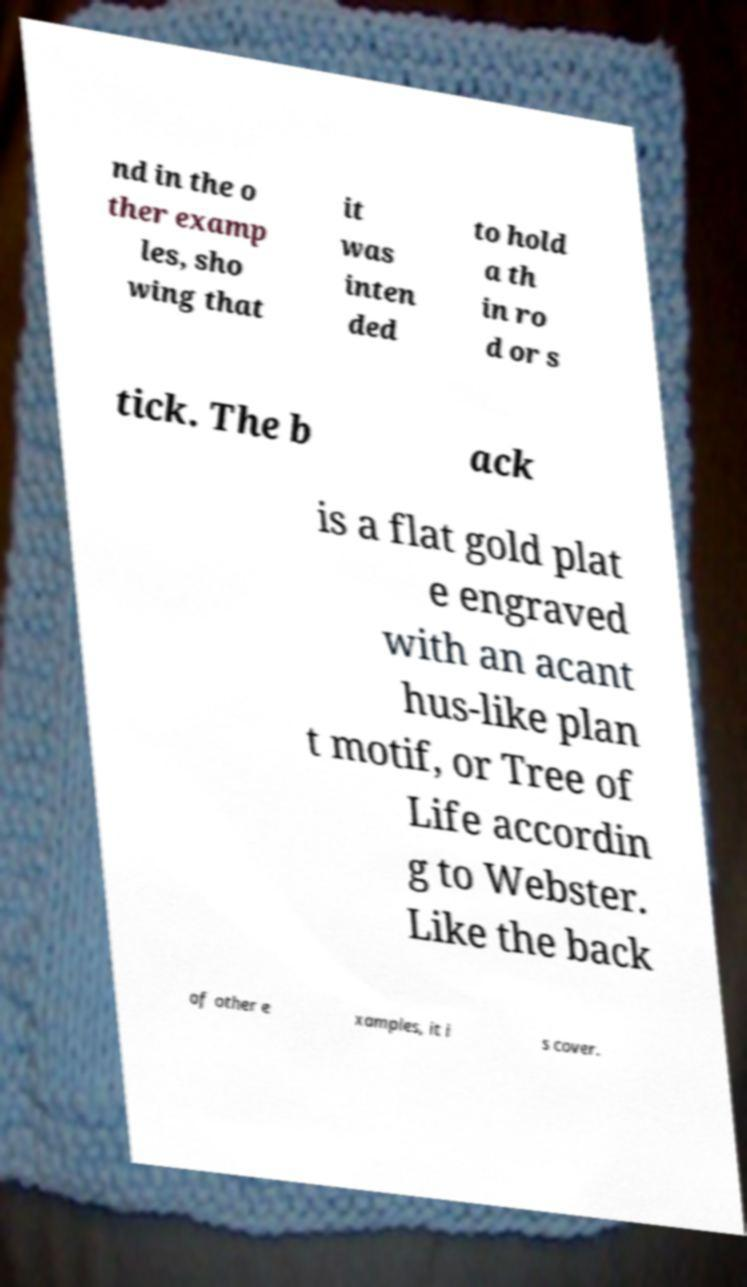There's text embedded in this image that I need extracted. Can you transcribe it verbatim? nd in the o ther examp les, sho wing that it was inten ded to hold a th in ro d or s tick. The b ack is a flat gold plat e engraved with an acant hus-like plan t motif, or Tree of Life accordin g to Webster. Like the back of other e xamples, it i s cover. 